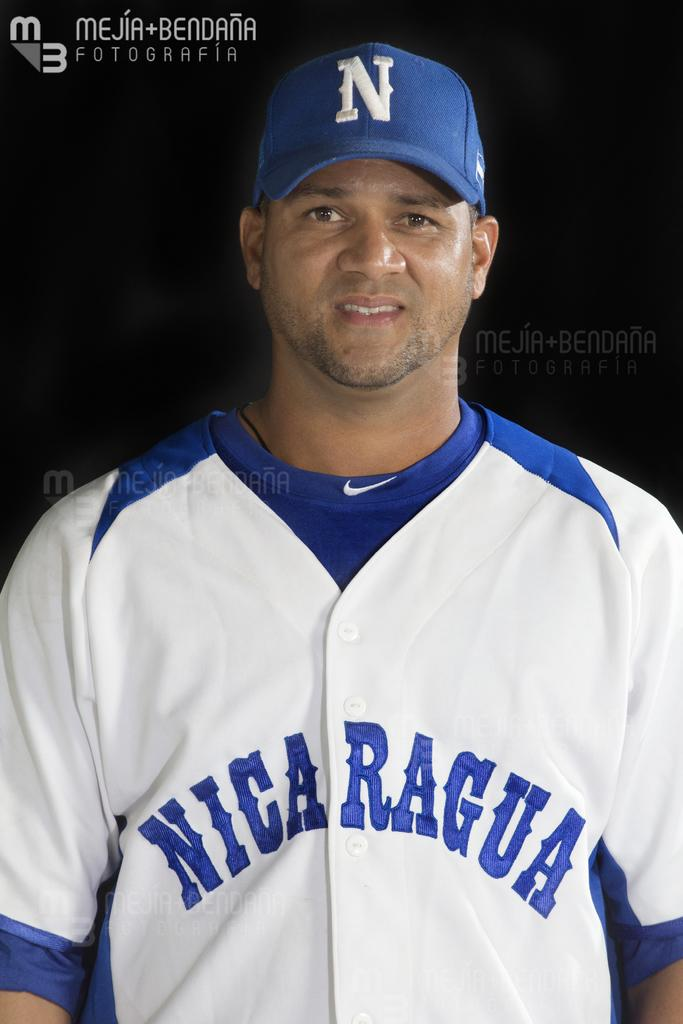<image>
Relay a brief, clear account of the picture shown. A baseball player from Nicaragua appears in uniform. 